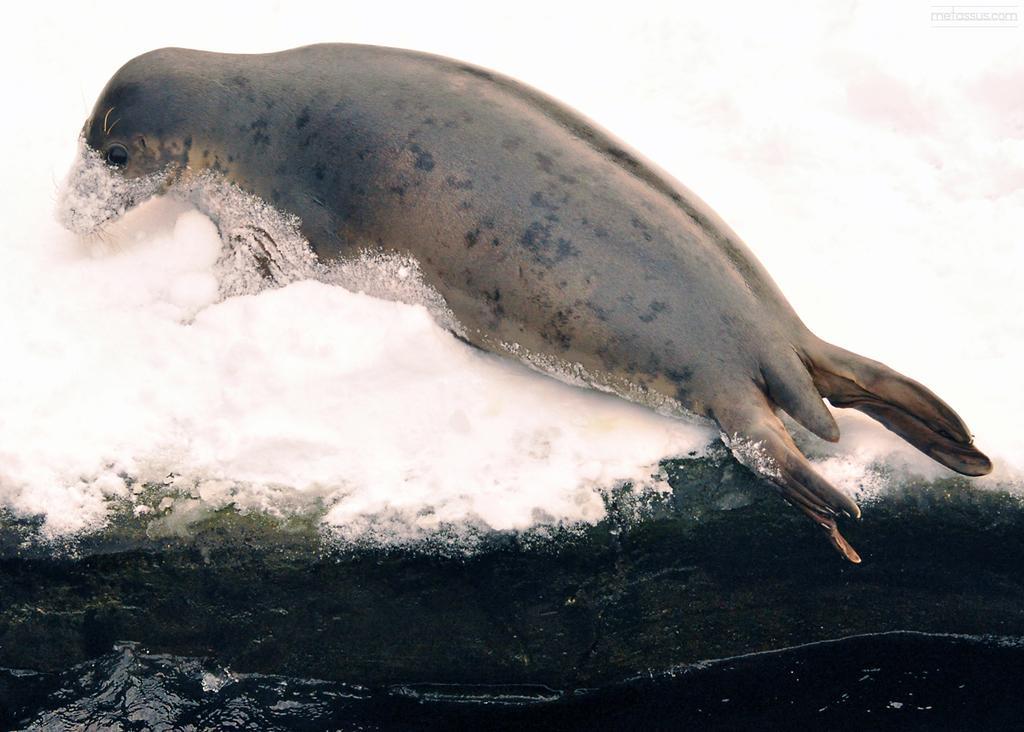Describe this image in one or two sentences. In the image we can see there is a seal lying on the ground and there is snow on the ground. There is water at the bottom. 